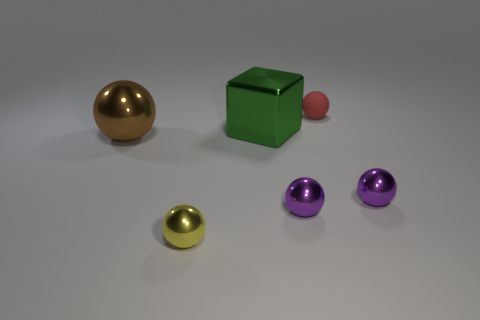Subtract all big brown metallic spheres. How many spheres are left? 4 Subtract all purple spheres. How many spheres are left? 3 Subtract all brown cylinders. How many purple balls are left? 2 Subtract 3 spheres. How many spheres are left? 2 Add 4 red things. How many objects exist? 10 Subtract all spheres. How many objects are left? 1 Subtract all big shiny things. Subtract all red matte objects. How many objects are left? 3 Add 4 big green cubes. How many big green cubes are left? 5 Add 5 large green shiny blocks. How many large green shiny blocks exist? 6 Subtract 0 gray cubes. How many objects are left? 6 